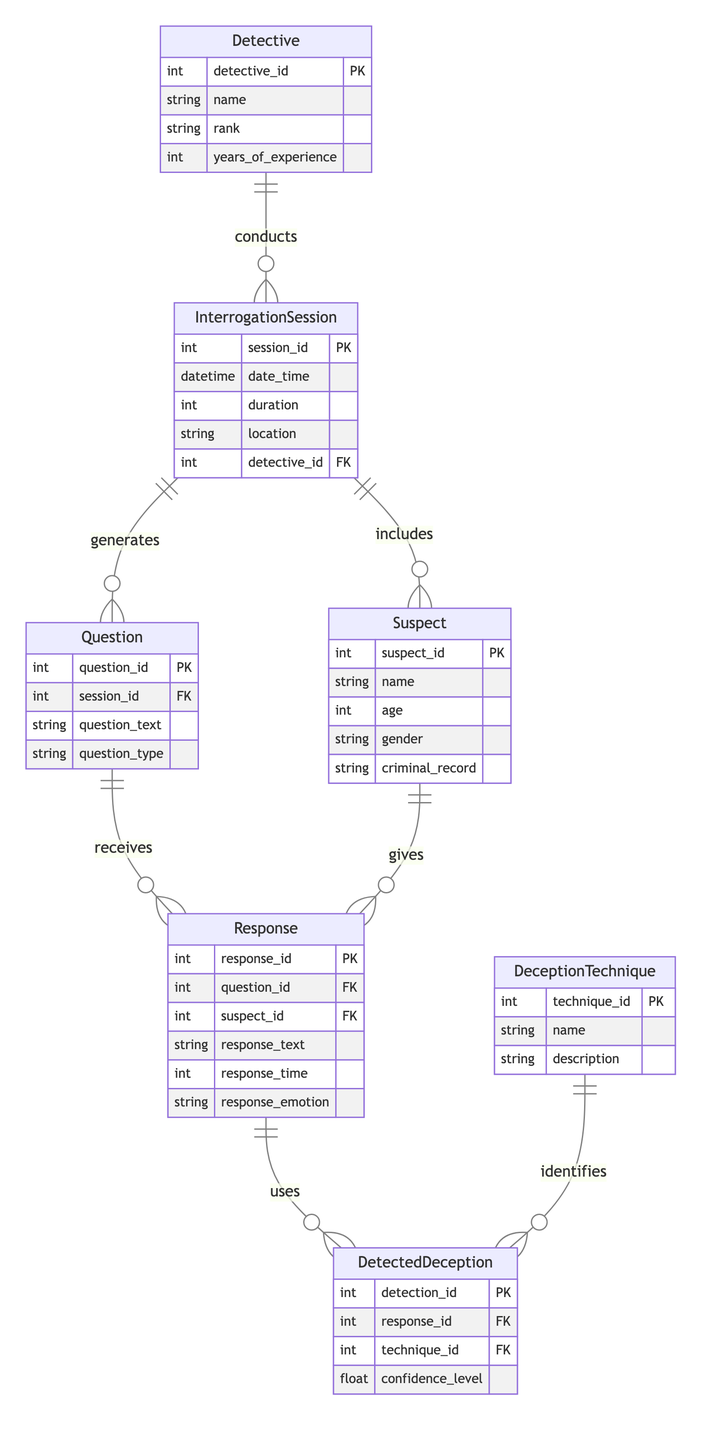What is the primary key of the InterrogationSession entity? The primary key for the InterrogationSession entity is indicated as "session_id," which uniquely identifies each session in the diagram.
Answer: session_id How many relationships are shown involving the Suspect entity? In the diagram, the Suspect entity has two relationships: "SessionIncludesSuspect" and "SuspectGivesResponse," indicating it’s involved in two relationships.
Answer: 2 What is the maximum number of Questions that can be generated in a single InterrogationSession? The relationship "SessionGeneratesQuestion" from InterrogationSession to Question is a 1:n relationship, meaning one session can generate multiple questions. The maximum is not specified, but it indicates there can be many.
Answer: many What attribute in the Response entity captures the emotional reaction of the suspect? The Response entity includes an attribute labeled "response_emotion," which is used to convey the emotional state or response of the suspect during the interrogation.
Answer: response_emotion Which entity has a relationship that detects deception techniques? The DetectedDeception entity has a relationship with both Response and DeceptionTechnique, indicating that it detects deception techniques based on responses.
Answer: DetectedDeception How many techniques are used for detection in the diagram? The DeceptionTechnique entity allows for multiple techniques to be utilized as indicated by the 1:n relationships connecting to DetectedDeception. However, the exact number of techniques is not stated in the diagram.
Answer: many What is the foreign key in the Response entity? The Response entity contains multiple foreign keys; however, the key specifically linking to a Question is labeled "question_id," which connects the response to the specific question asked.
Answer: question_id What is the main function of the Detective entity in the diagram? The Detective entity primarily conducts InterrogationSessions, as represented by the "DetectiveConductsSession" relationship, which shows that a detective is responsible for leading the interrogations.
Answer: conducts sessions What type of relationship exists between the Question and Response entities? The relationship between Question and Response is a 1:n relationship, which means for each question, there can be multiple responses given by the suspect.
Answer: 1:n 